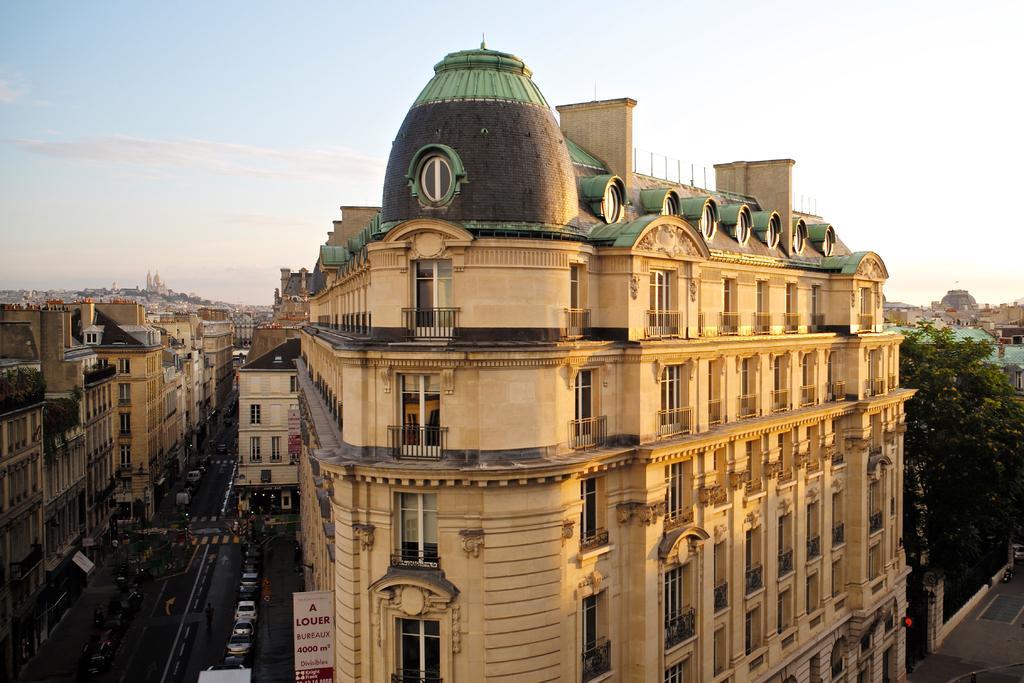Please provide a concise description of this image. In this image we can see buildings, railings, name board, road, vehicles, person and other objects. On the left side of the image there are buildings and other objects. On the right side of the image there are buildings, trees, road and other objects. At the top of the image there is the sky. 